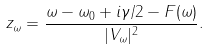<formula> <loc_0><loc_0><loc_500><loc_500>z _ { \omega } = \frac { \omega - \omega _ { 0 } + i \gamma / 2 - F ( \omega ) } { | V _ { \omega } | ^ { 2 } } .</formula> 